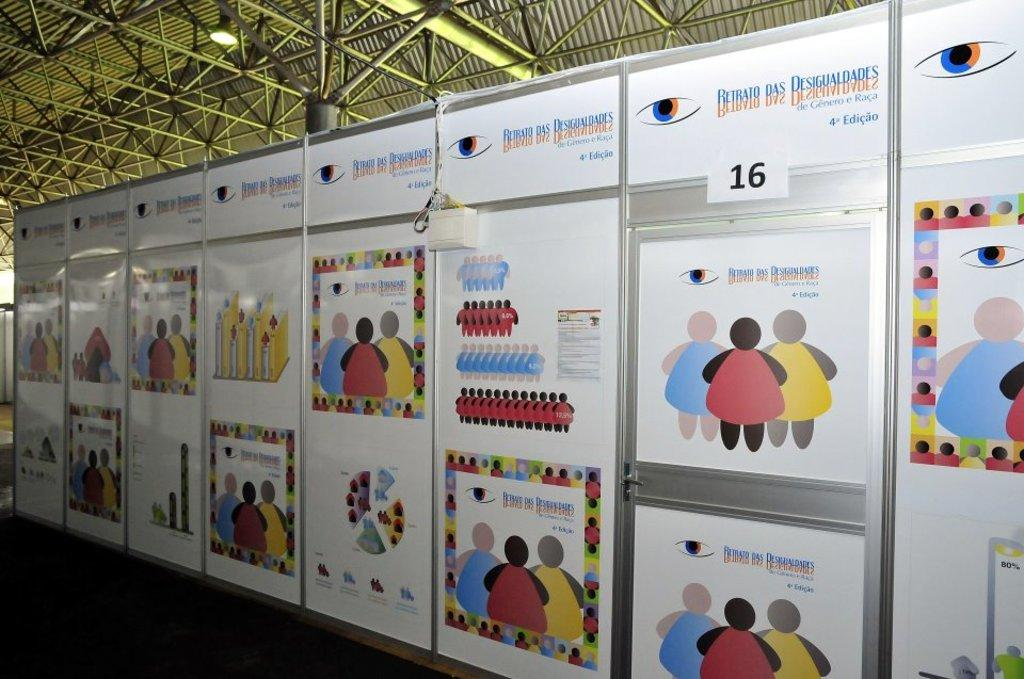<image>
Summarize the visual content of the image. colorful display of pictures on Retrato Das Desigualdades boards 